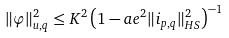<formula> <loc_0><loc_0><loc_500><loc_500>\| \varphi \| ^ { 2 } _ { u , q } \leq K ^ { 2 } \left ( 1 - a e ^ { 2 } \| i _ { p , q } \| ^ { 2 } _ { H S } \right ) ^ { - 1 }</formula> 